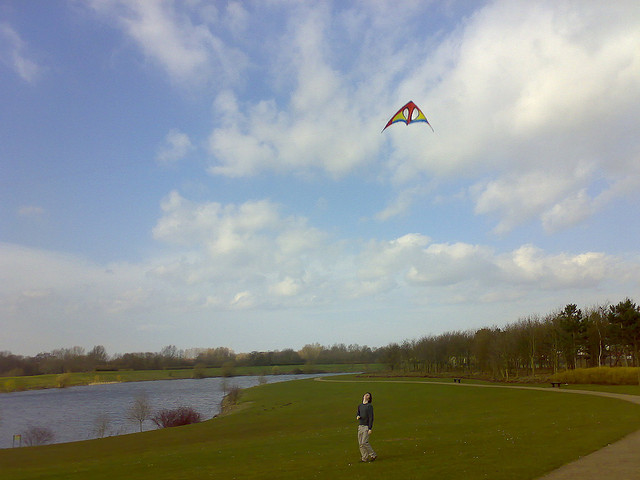How many little girls can be seen? 0 